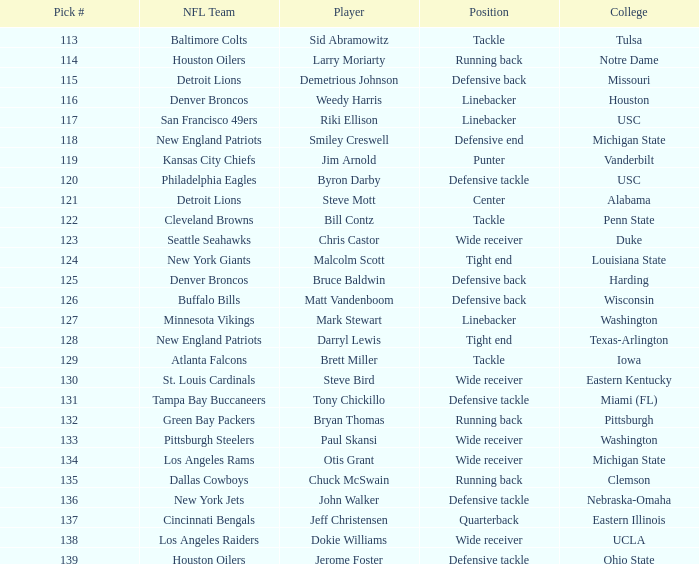What pick number did the buffalo bills get? 126.0. 